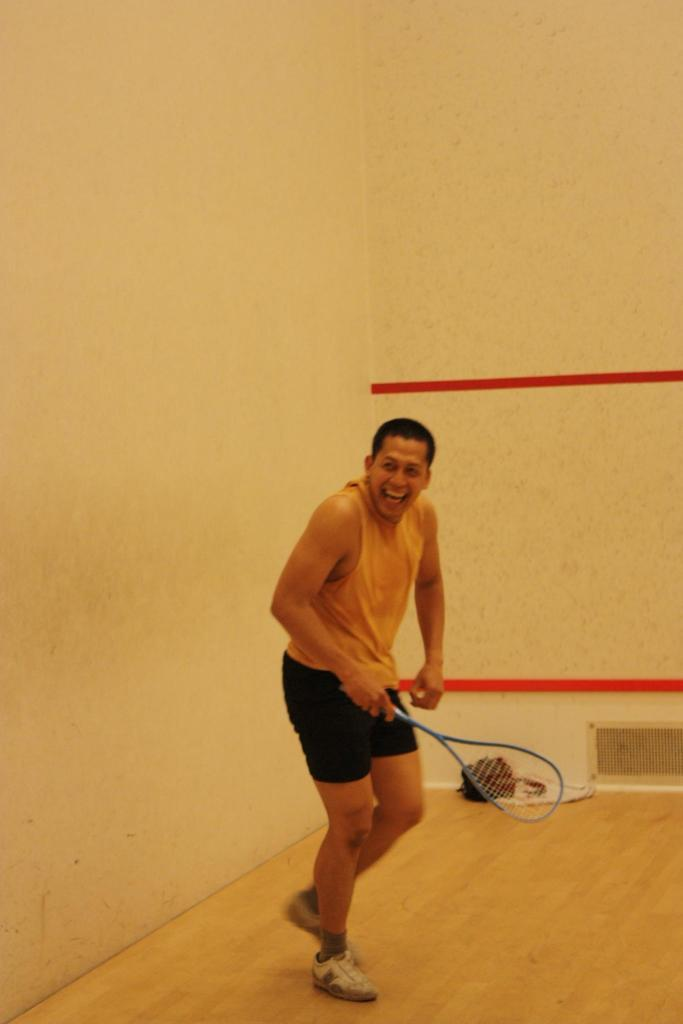What is the main subject of the image? The main subject of the image is a man. What is the man wearing on his upper body? The man is wearing a yellow shirt. What is the man wearing on his lower body? The man is wearing black shorts. What object is the man holding in his hand? The man is holding a racket in his hand. What is the man's facial expression in the image? The man is laughing. Where is the man located in the image? The man is inside a room. What type of footwear is the man wearing? The man is wearing shoes. What is the weight of the structure the man is standing on in the image? There is no structure mentioned in the image; the man is inside a room. Can you tell me how many flights the man has taken to reach his current location in the image? There is no information about flights or travel in the image; the man is simply inside a room. 